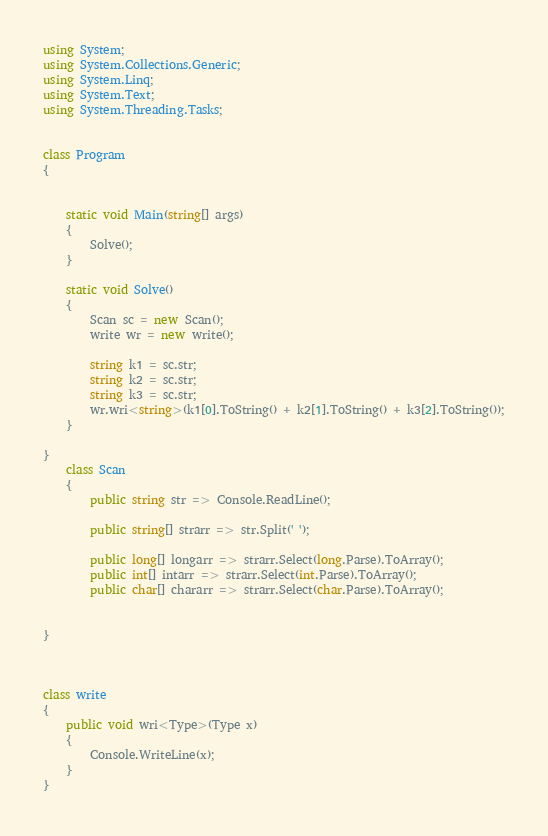Convert code to text. <code><loc_0><loc_0><loc_500><loc_500><_C#_>using System;
using System.Collections.Generic;
using System.Linq;
using System.Text;
using System.Threading.Tasks;


class Program
{


    static void Main(string[] args)
    {
        Solve();
    }

    static void Solve()
    {
        Scan sc = new Scan();
        write wr = new write();

        string k1 = sc.str;
        string k2 = sc.str;
        string k3 = sc.str;
        wr.wri<string>(k1[0].ToString() + k2[1].ToString() + k3[2].ToString());
    }

}
    class Scan
    {
        public string str => Console.ReadLine();

        public string[] strarr => str.Split(' ');

        public long[] longarr => strarr.Select(long.Parse).ToArray();
        public int[] intarr => strarr.Select(int.Parse).ToArray();
        public char[] chararr => strarr.Select(char.Parse).ToArray();


}



class write
{
    public void wri<Type>(Type x)
    {
        Console.WriteLine(x);
    }
}
</code> 